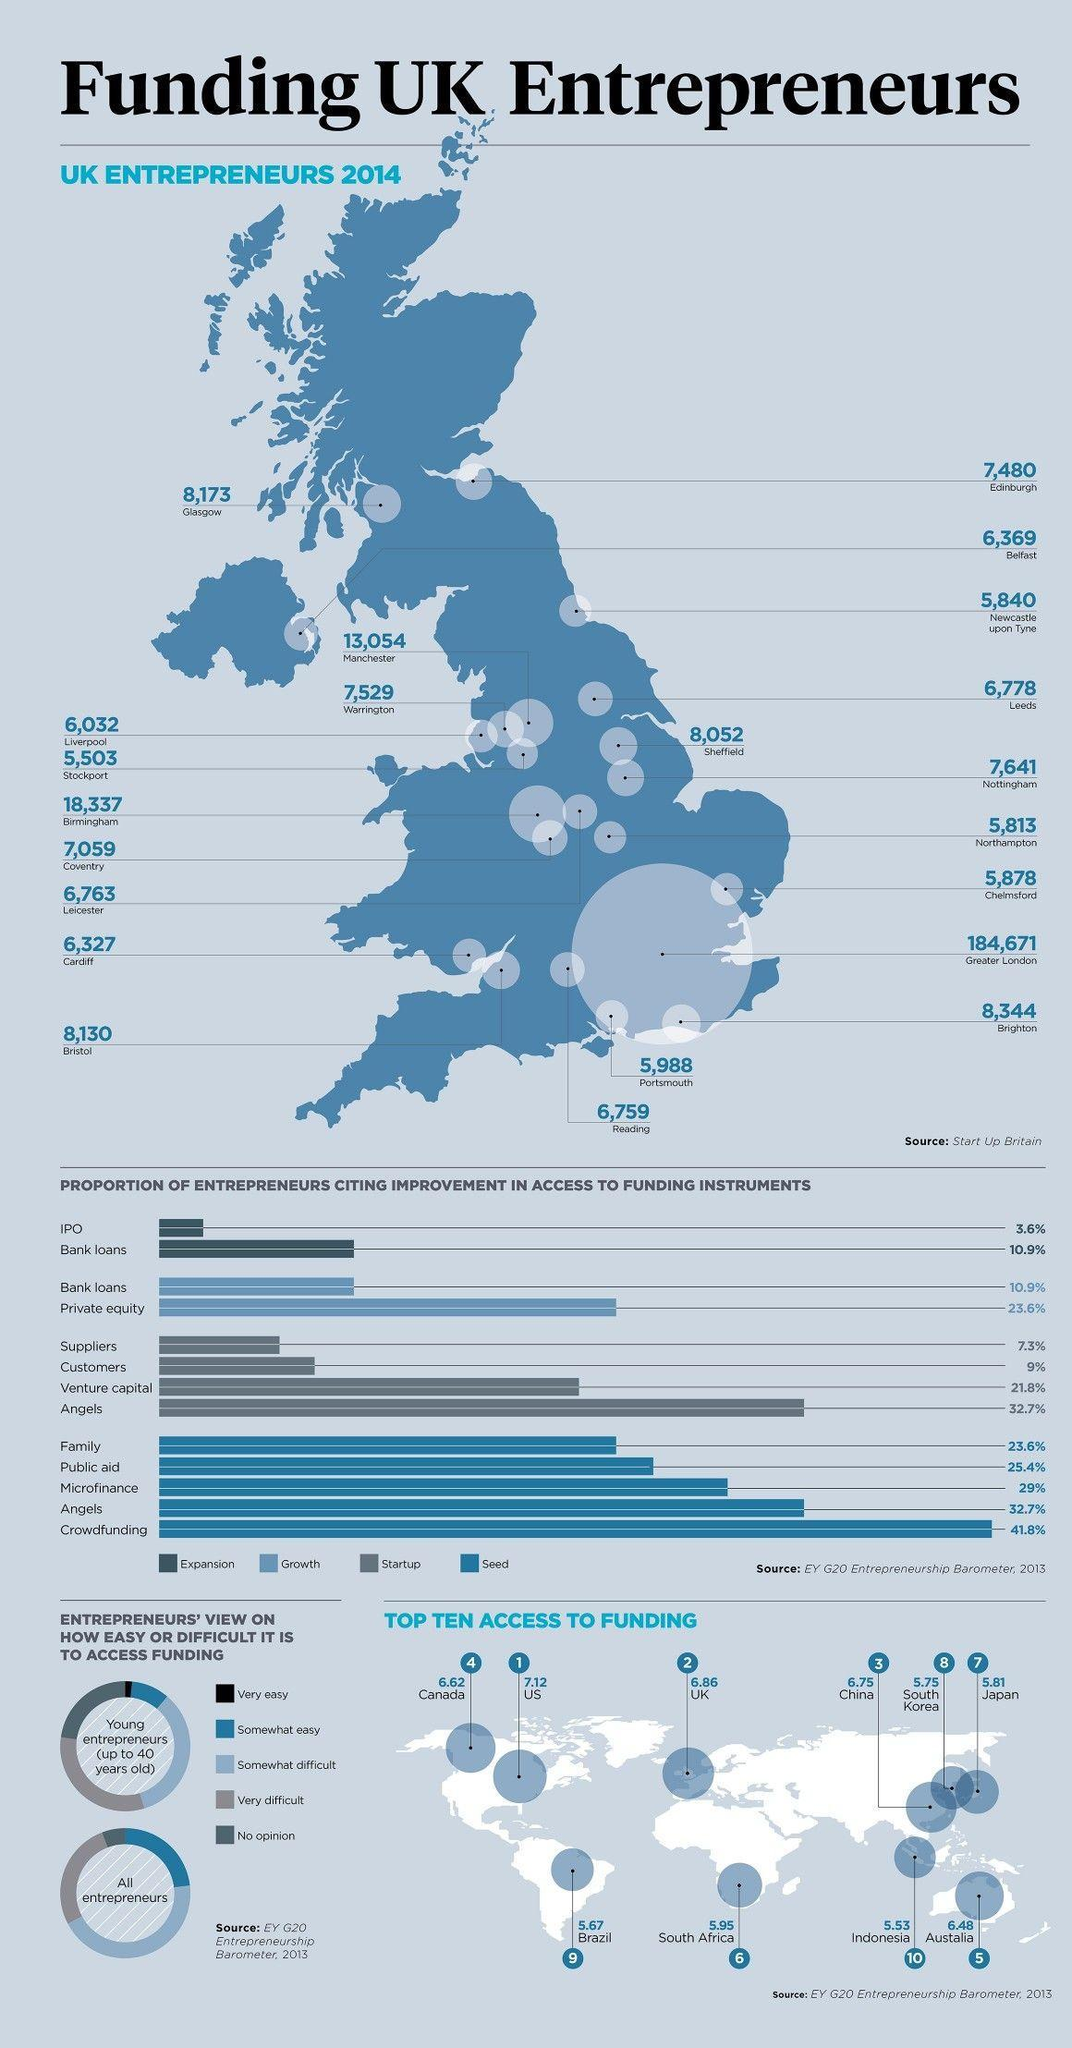What is the opinion of majority of all entrepreneurs about access to funding?
Answer the question with a short phrase. somewhat difficult Which city saw the third highest number of start ups in 2014? Manchester Which country is at the 10th position in the list of top ten access to funding? Indonesia The second highest number of entrepreneurs was in which city? Birmingham How many start ups were registered in the city of Cardiff in 2014? 6,327 At what position is Brazil in the list of top ten access to funding? 9 In the list of top ten access to funding, at what position is the US? 1 Which location has the highest number of entrepreneurs? Greater London 